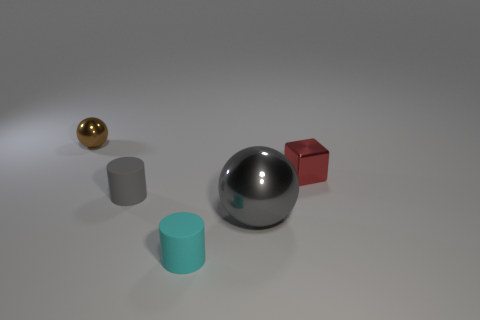There is a metal thing behind the tiny red thing; is its shape the same as the red shiny thing?
Give a very brief answer. No. There is a tiny shiny object that is on the right side of the sphere on the left side of the metallic thing that is in front of the metal block; what is its shape?
Your answer should be very brief. Cube. There is another rubber thing that is the same color as the big object; what shape is it?
Your answer should be very brief. Cylinder. There is a thing that is both to the right of the cyan cylinder and left of the tiny red metal cube; what is it made of?
Keep it short and to the point. Metal. Is the number of yellow shiny spheres less than the number of gray spheres?
Your answer should be very brief. Yes. Does the big gray shiny object have the same shape as the metallic object that is to the right of the big gray object?
Your answer should be very brief. No. Does the cyan rubber cylinder that is in front of the brown ball have the same size as the tiny gray matte cylinder?
Provide a short and direct response. Yes. What shape is the red object that is the same size as the cyan thing?
Your response must be concise. Cube. Is the small cyan matte object the same shape as the large gray metal thing?
Your response must be concise. No. What number of other red objects have the same shape as the large thing?
Give a very brief answer. 0. 